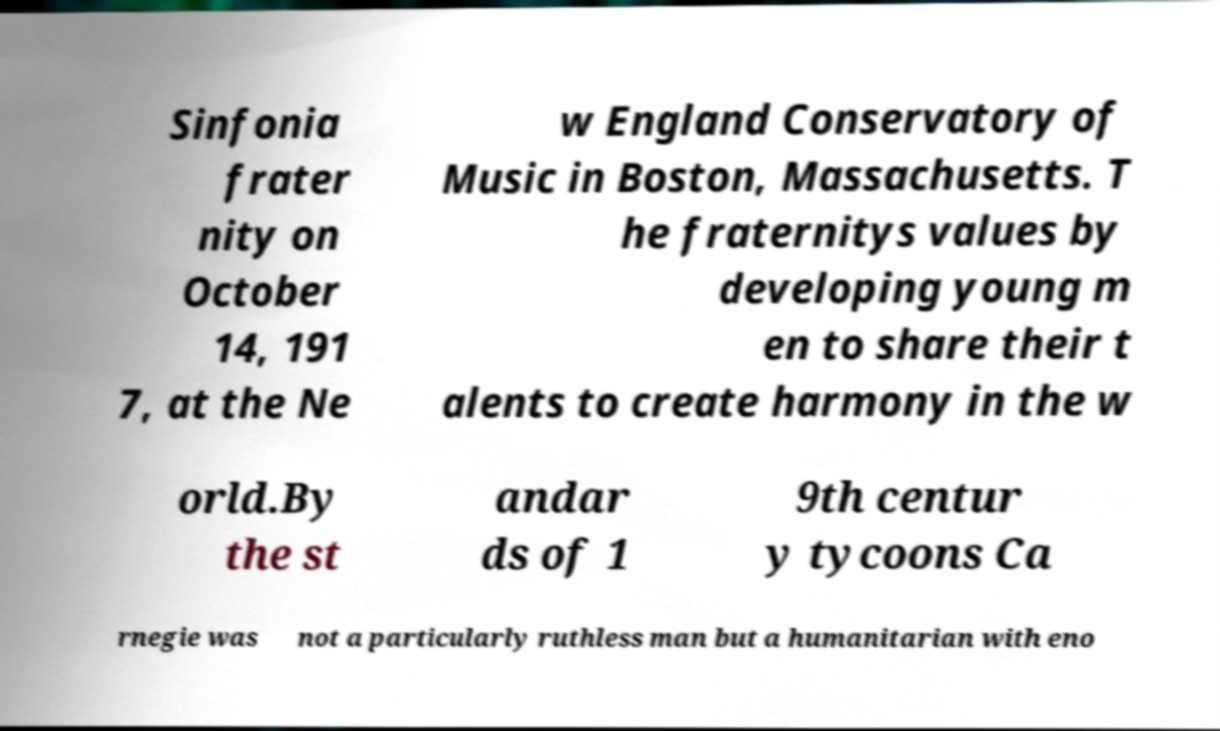What messages or text are displayed in this image? I need them in a readable, typed format. Sinfonia frater nity on October 14, 191 7, at the Ne w England Conservatory of Music in Boston, Massachusetts. T he fraternitys values by developing young m en to share their t alents to create harmony in the w orld.By the st andar ds of 1 9th centur y tycoons Ca rnegie was not a particularly ruthless man but a humanitarian with eno 